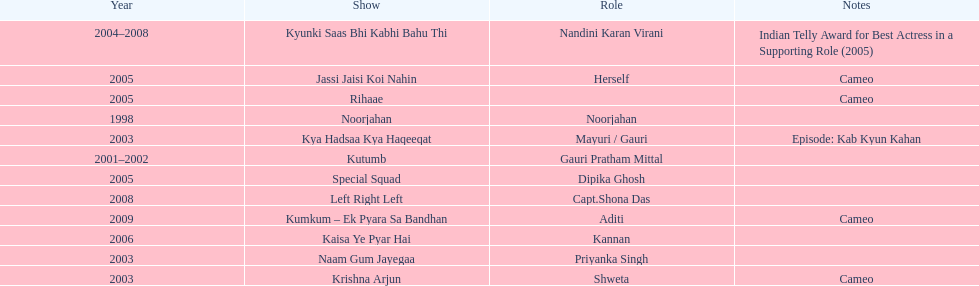Which was the only television show gauri starred in, in which she played herself? Jassi Jaisi Koi Nahin. 